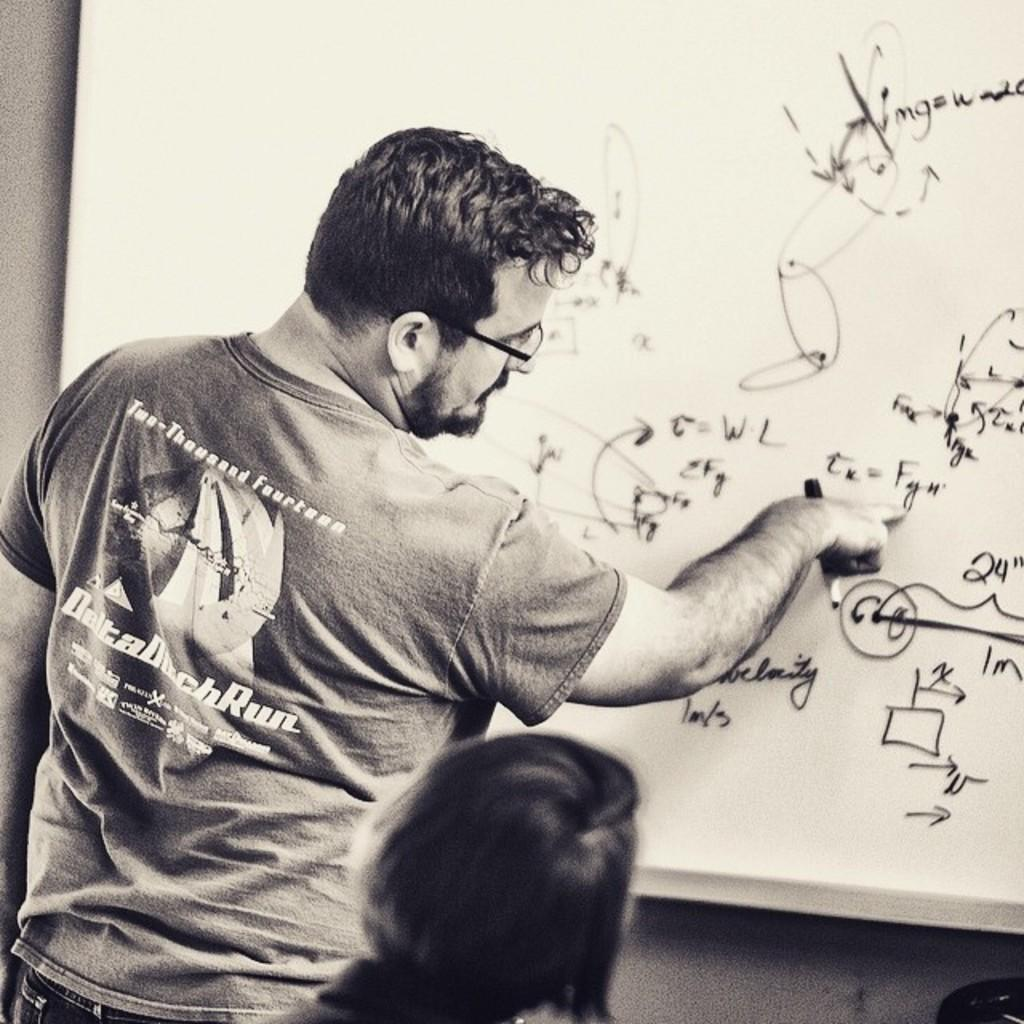<image>
Provide a brief description of the given image. A man with a shirt from two-thousand and fourteen draws on a white board. 